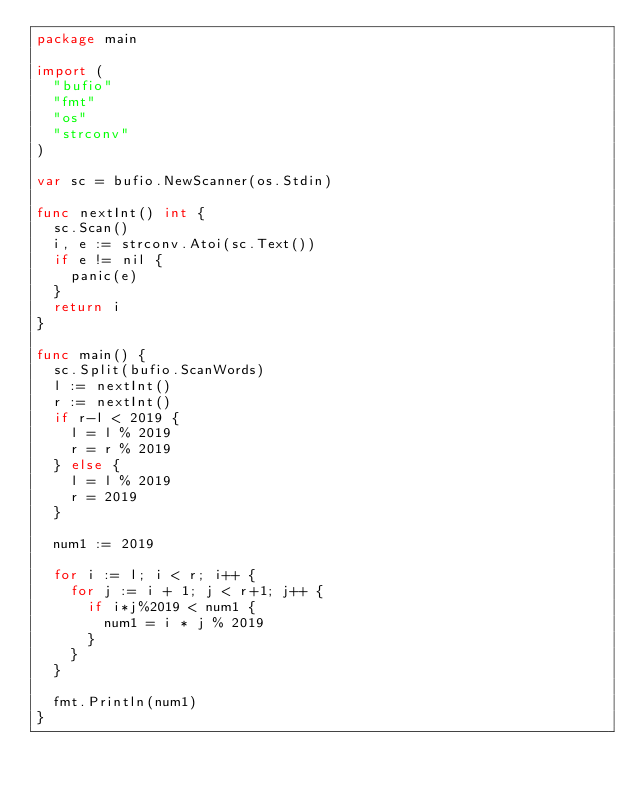Convert code to text. <code><loc_0><loc_0><loc_500><loc_500><_Go_>package main

import (
	"bufio"
	"fmt"
	"os"
	"strconv"
)

var sc = bufio.NewScanner(os.Stdin)

func nextInt() int {
	sc.Scan()
	i, e := strconv.Atoi(sc.Text())
	if e != nil {
		panic(e)
	}
	return i
}

func main() {
	sc.Split(bufio.ScanWords)
	l := nextInt()
	r := nextInt()
	if r-l < 2019 {
		l = l % 2019
		r = r % 2019
	} else {
		l = l % 2019
		r = 2019
	}

	num1 := 2019

	for i := l; i < r; i++ {
		for j := i + 1; j < r+1; j++ {
			if i*j%2019 < num1 {
				num1 = i * j % 2019
			}
		}
	}

	fmt.Println(num1)
}
</code> 